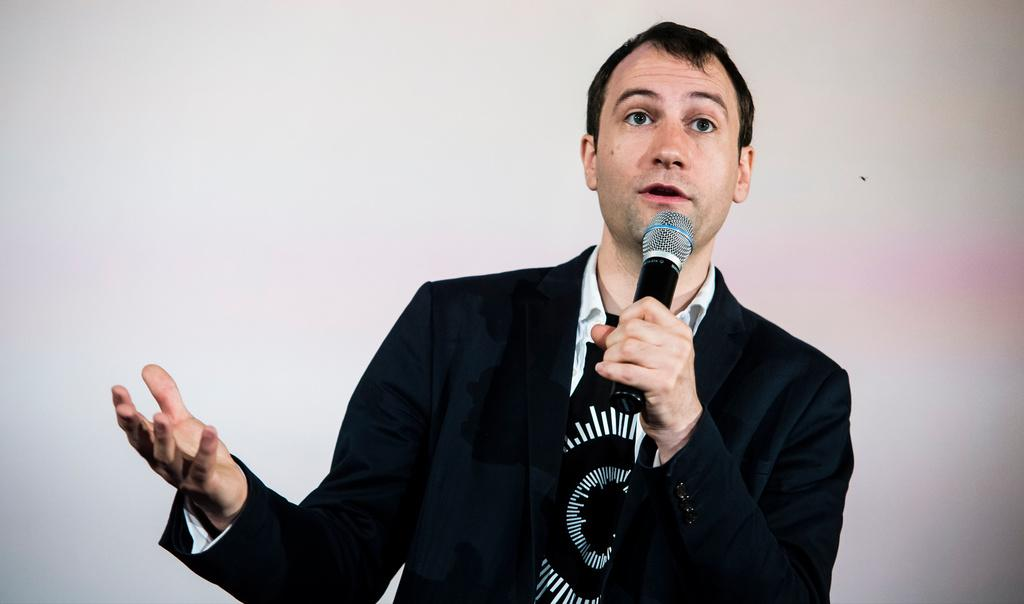Who is the main subject in the image? There is a man in the image. What is the man wearing? The man is wearing a black blazer. What is the man holding in his hand? The man is holding a mic in his hand. What might the man be doing in the image? The man appears to be talking, as he is holding a mic. How does the man increase the temperature in the image? There is no indication in the image that the man is increasing the temperature; he is simply holding a mic and appears to be talking. 